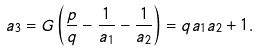Convert formula to latex. <formula><loc_0><loc_0><loc_500><loc_500>a _ { 3 } = G \left ( \frac { p } { q } - \frac { 1 } { a _ { 1 } } - \frac { 1 } { a _ { 2 } } \right ) = q a _ { 1 } a _ { 2 } + 1 .</formula> 